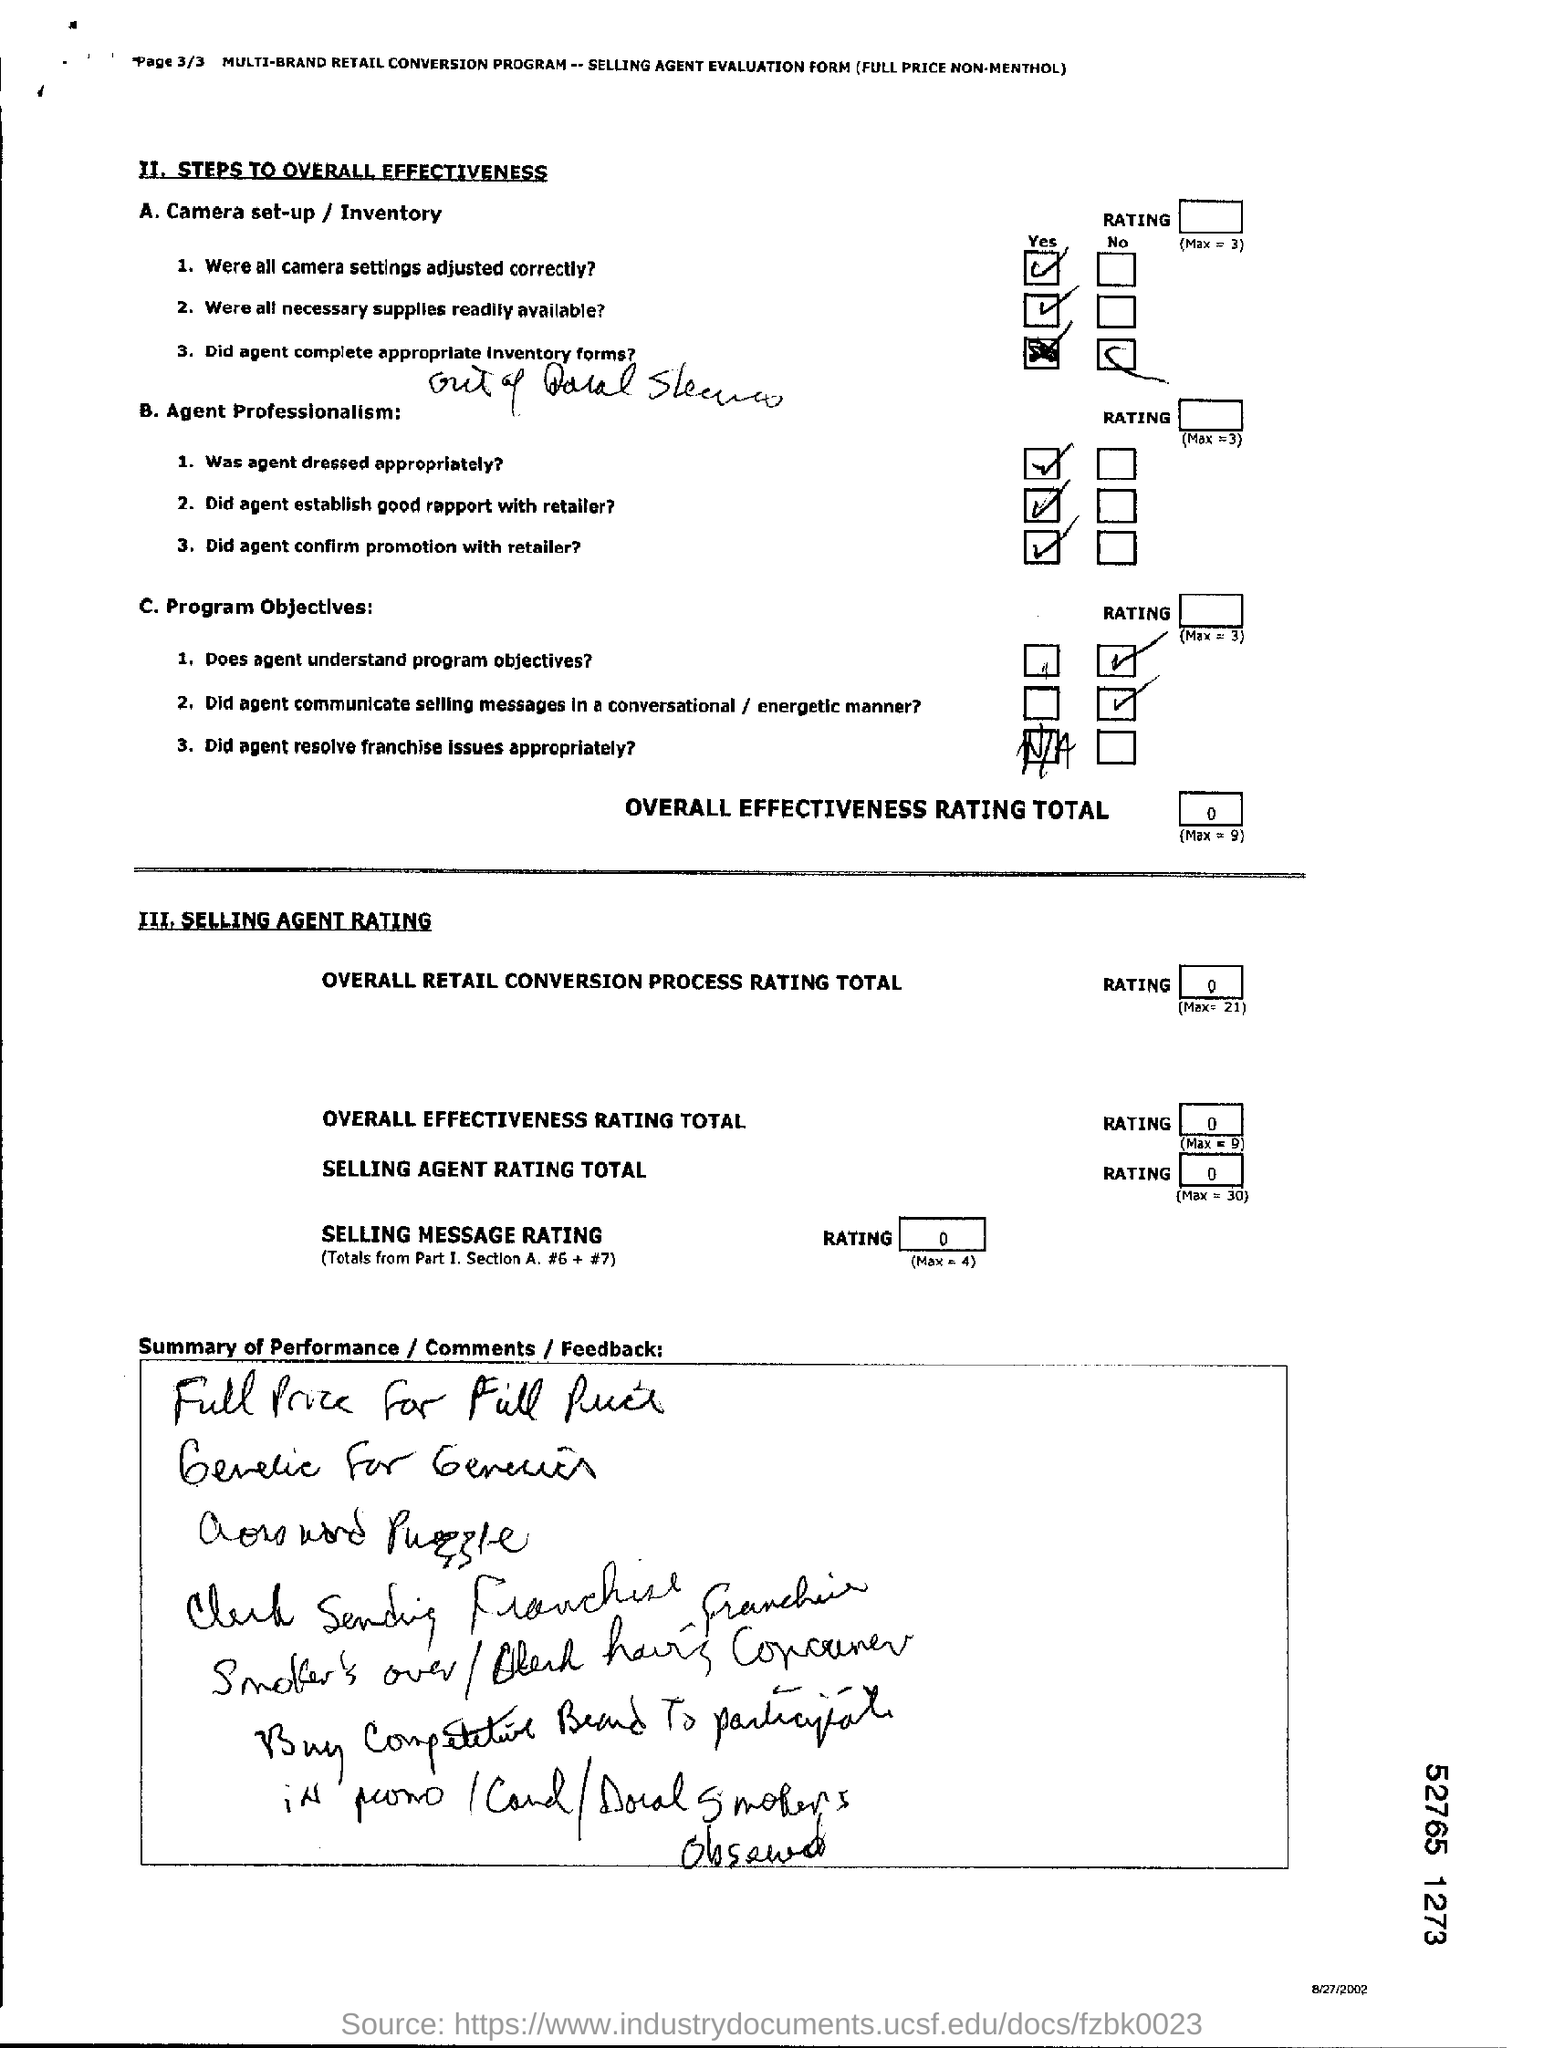What improvements could be suggested to enhance the effectiveness of the selling agent, based on this evaluation? Given the assessment areas lacking maximum marks, feedback for improvement might include reiterating the importance of program objectives to the agent, encouraging clearer communication of selling messages, and perhaps suggesting more engaging methods of interacting with consumers. The agent could also benefit from additional training to better understand the promotional strategies and to resolve franchise issues that contribute to the overall effectiveness. The specific feedback section of the document should be utilized to provide detailed, constructive comments that can guide the agent towards better performance. 